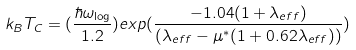<formula> <loc_0><loc_0><loc_500><loc_500>k _ { B } T _ { C } = ( \frac { \hbar { \omega } _ { \log } } { 1 . 2 } ) e x p ( \frac { - 1 . 0 4 ( 1 + \lambda _ { e f f } ) } { ( \lambda _ { e f f } - \mu ^ { * } ( 1 + 0 . 6 2 \lambda _ { e f f } ) ) } )</formula> 